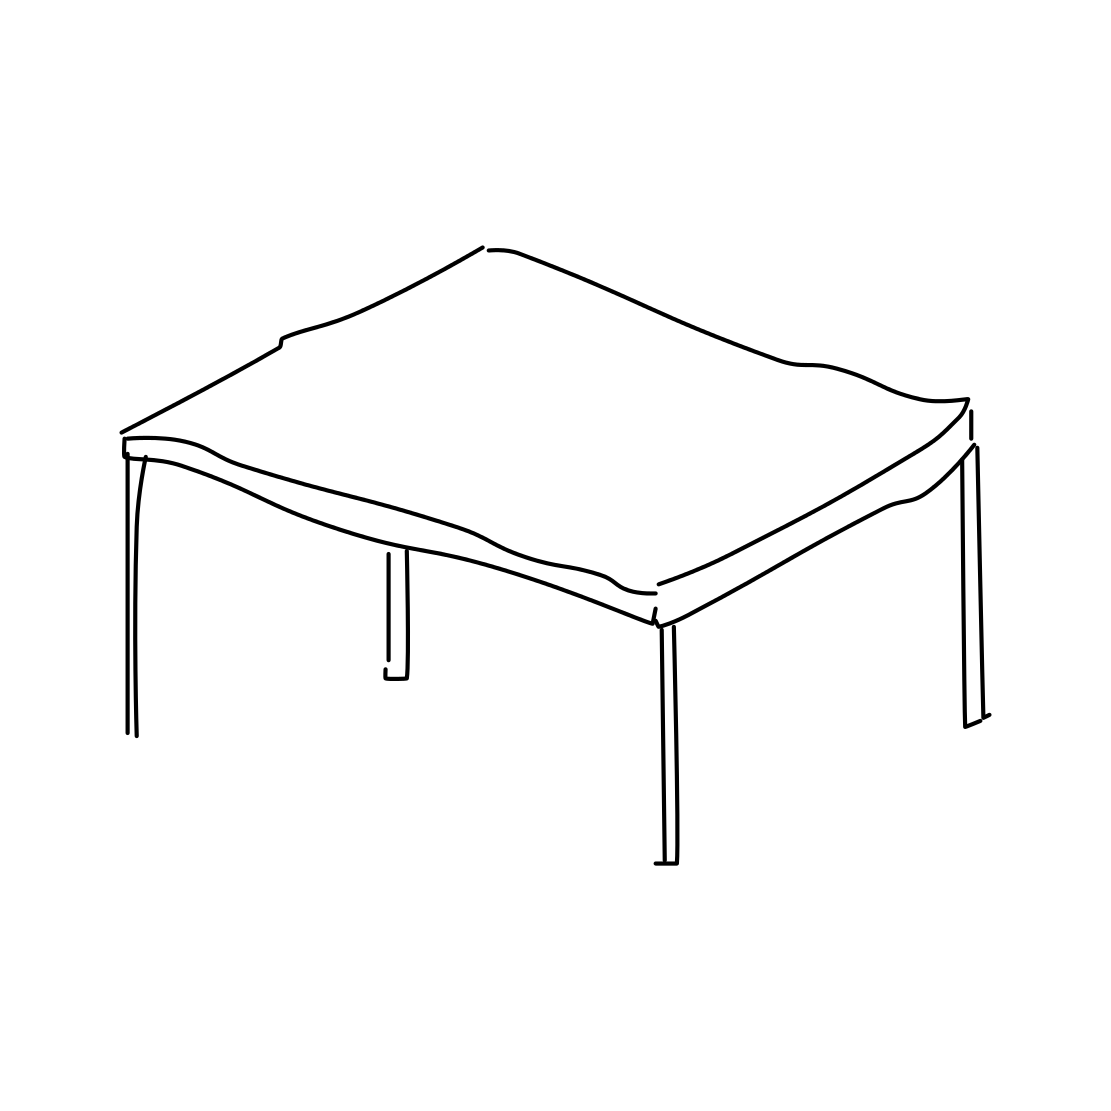Can you describe the object in the image? Certainly! The image displays a line drawing of a four-legged table. The tabletop appears to be rectangular with a subtly indicated thickness, and the legs are simple straight lines that extend downward, suggesting a minimalistic and practical design.  Does this table look like it's designed for indoor or outdoor use? Based on the clean lines and straightforward design presented, it could easily complement either an indoor or outdoor setting. However, without additional context such as material or finish, it's difficult to determine the designer's intent with certainty. 